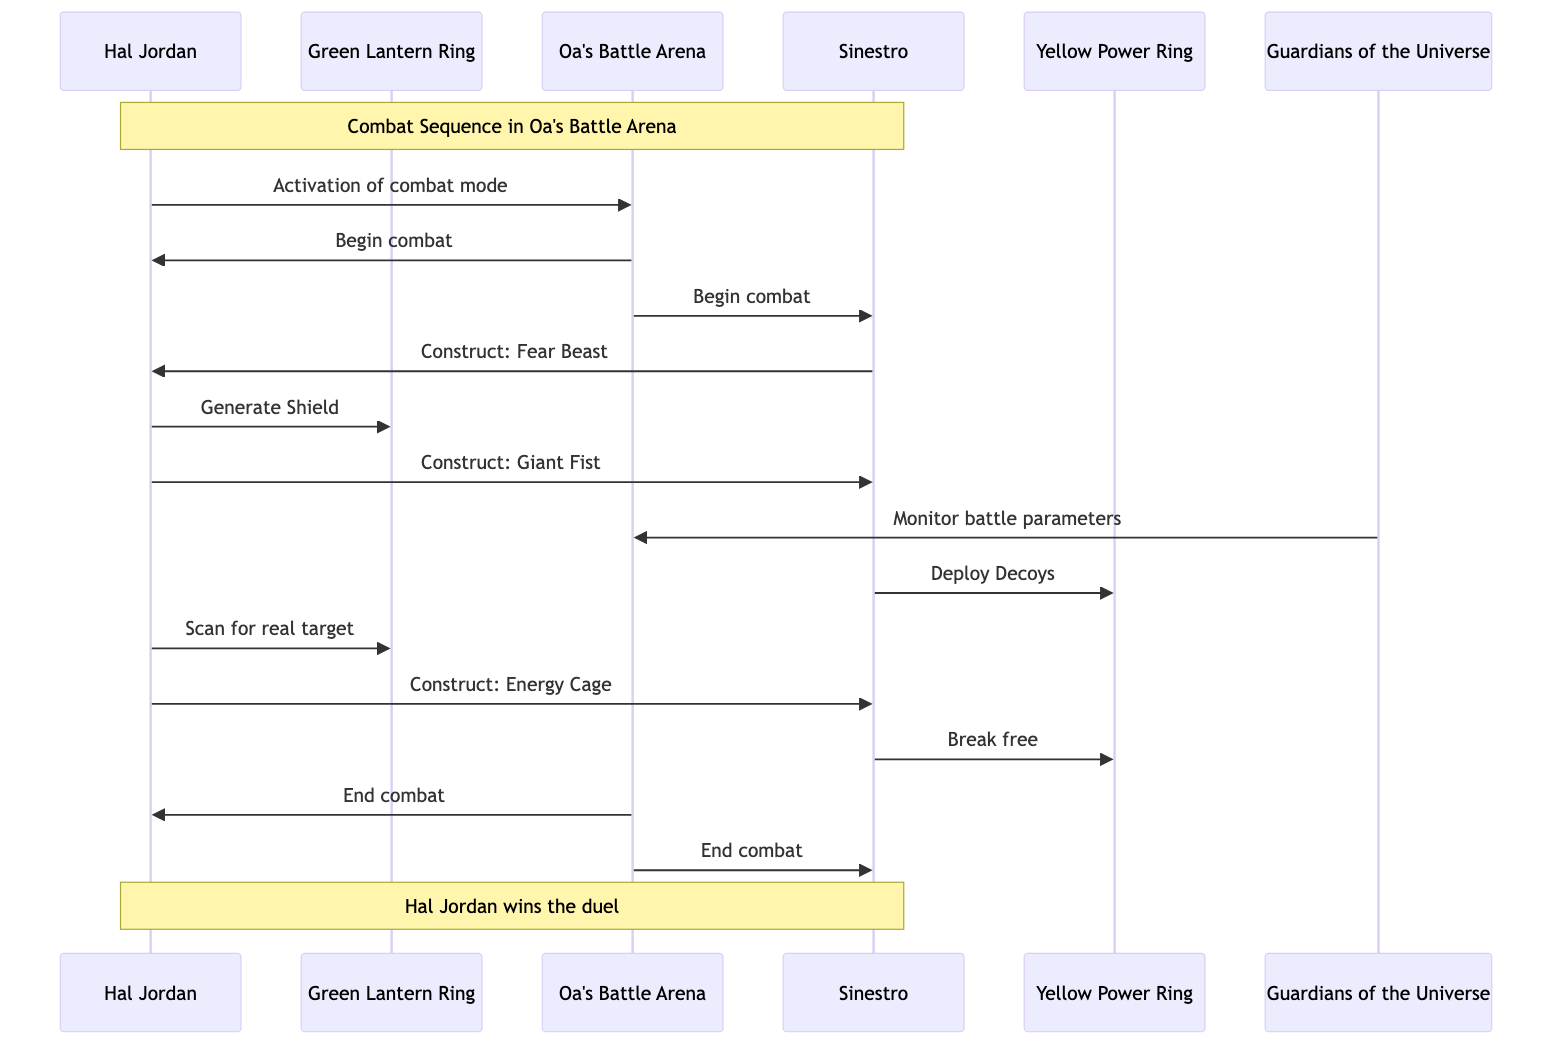What is the name of the first actor in the diagram? The first actor listed in the diagram is Hal Jordan, who is identified by the description provided.
Answer: Hal Jordan How many participants are involved in the combat sequence? The diagram includes five participants: Hal Jordan, Sinestro, Green Lantern Ring, Yellow Power Ring, and Guardians of the Universe. Counting them gives a total of five.
Answer: 5 What does Hal Jordan instruct his Green Lantern ring to do after Sinestro deploys decoys? Hal Jordan instructs his Green Lantern ring to scan for the real target after Sinestro deploys the decoys, as indicated in the sequence of messages.
Answer: Scan for real target What construct does Sinestro create to attack Hal Jordan? Sinestro creates a construct in the form of a fearsome beast, which is explicitly mentioned in the sequence of messages.
Answer: Fear Beast What is the last message sent in the sequence? The last message sent in the sequence is "End combat," which is sent from Oa's Battle Arena to both Hal Jordan and Sinestro, marking the conclusion of the duel.
Answer: End combat How does Hal Jordan counteract Sinestro’s attack? Hal Jordan counters Sinestro's attack by generating a protective shield with his Green Lantern ring, as shown in the sequence of actions performed by him.
Answer: Generate Shield What is the outcome of the duel as indicated in the notes? The notes indicate that Hal Jordan wins the duel, which summarizes the result of the combat sequence in a straightforward statement.
Answer: Hal Jordan wins the duel What monitoring action do the Guardians of the Universe perform during the combat? The Guardians of the Universe monitor the battle parameters, as stated in the sequence, to ensure that the combat remains within acceptable limits.
Answer: Monitor battle parameters Which participant directs an action toward the Yellow Power Ring? Sinestro directs an action toward the Yellow Power Ring when he commands it to deploy decoys, showcasing his interaction with the object he controls.
Answer: Sinestro 